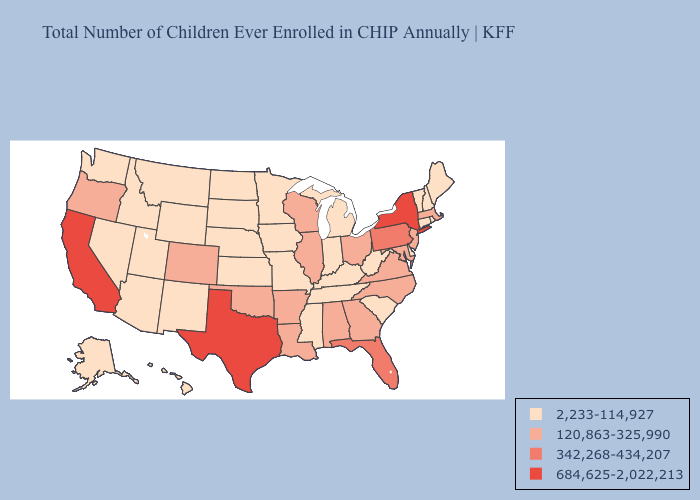Among the states that border Oregon , which have the lowest value?
Quick response, please. Idaho, Nevada, Washington. Does Idaho have the same value as Tennessee?
Short answer required. Yes. Name the states that have a value in the range 342,268-434,207?
Short answer required. Florida, Pennsylvania. Does Oregon have the same value as Nebraska?
Quick response, please. No. Does New York have the highest value in the Northeast?
Keep it brief. Yes. What is the value of Oklahoma?
Quick response, please. 120,863-325,990. Does New York have the highest value in the Northeast?
Answer briefly. Yes. What is the value of New Hampshire?
Keep it brief. 2,233-114,927. What is the value of Maine?
Keep it brief. 2,233-114,927. Which states have the lowest value in the USA?
Answer briefly. Alaska, Arizona, Connecticut, Delaware, Hawaii, Idaho, Indiana, Iowa, Kansas, Kentucky, Maine, Michigan, Minnesota, Mississippi, Missouri, Montana, Nebraska, Nevada, New Hampshire, New Mexico, North Dakota, Rhode Island, South Carolina, South Dakota, Tennessee, Utah, Vermont, Washington, West Virginia, Wyoming. Name the states that have a value in the range 120,863-325,990?
Quick response, please. Alabama, Arkansas, Colorado, Georgia, Illinois, Louisiana, Maryland, Massachusetts, New Jersey, North Carolina, Ohio, Oklahoma, Oregon, Virginia, Wisconsin. Name the states that have a value in the range 2,233-114,927?
Short answer required. Alaska, Arizona, Connecticut, Delaware, Hawaii, Idaho, Indiana, Iowa, Kansas, Kentucky, Maine, Michigan, Minnesota, Mississippi, Missouri, Montana, Nebraska, Nevada, New Hampshire, New Mexico, North Dakota, Rhode Island, South Carolina, South Dakota, Tennessee, Utah, Vermont, Washington, West Virginia, Wyoming. Is the legend a continuous bar?
Short answer required. No. Name the states that have a value in the range 342,268-434,207?
Short answer required. Florida, Pennsylvania. Which states have the lowest value in the USA?
Answer briefly. Alaska, Arizona, Connecticut, Delaware, Hawaii, Idaho, Indiana, Iowa, Kansas, Kentucky, Maine, Michigan, Minnesota, Mississippi, Missouri, Montana, Nebraska, Nevada, New Hampshire, New Mexico, North Dakota, Rhode Island, South Carolina, South Dakota, Tennessee, Utah, Vermont, Washington, West Virginia, Wyoming. 